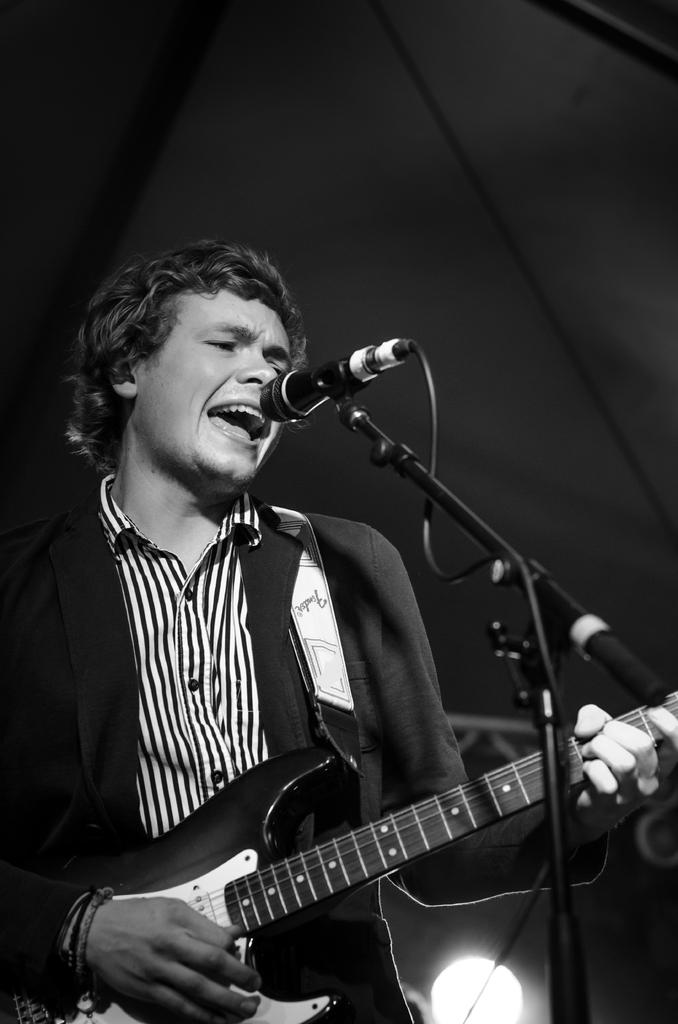What is the man in the image doing? The man is standing, playing a guitar, singing, and using a microphone. Can you describe the man's actions in more detail? The man is playing a guitar and singing while using a microphone. What might be the purpose of the microphone in the image? The microphone is likely being used to amplify the man's singing voice. What type of trade is the man conducting in the image? There is no indication of any trade activity in the image; the man is playing a guitar, singing, and using a microphone. 